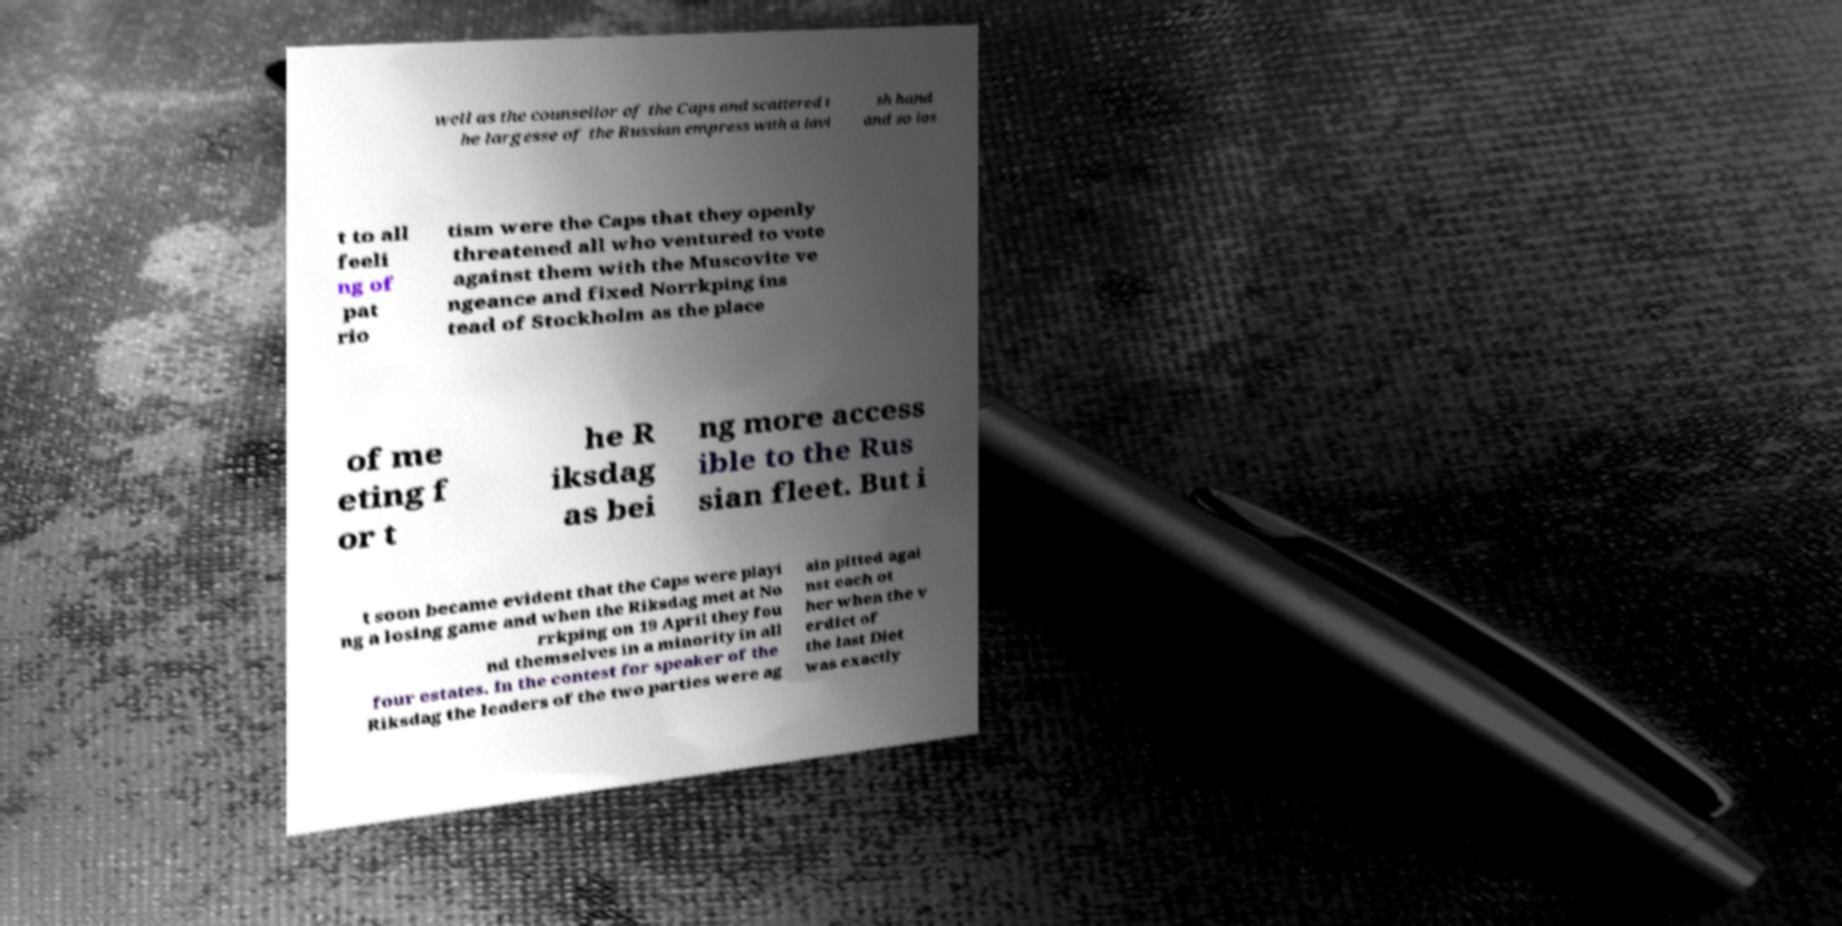What messages or text are displayed in this image? I need them in a readable, typed format. well as the counsellor of the Caps and scattered t he largesse of the Russian empress with a lavi sh hand and so los t to all feeli ng of pat rio tism were the Caps that they openly threatened all who ventured to vote against them with the Muscovite ve ngeance and fixed Norrkping ins tead of Stockholm as the place of me eting f or t he R iksdag as bei ng more access ible to the Rus sian fleet. But i t soon became evident that the Caps were playi ng a losing game and when the Riksdag met at No rrkping on 19 April they fou nd themselves in a minority in all four estates. In the contest for speaker of the Riksdag the leaders of the two parties were ag ain pitted agai nst each ot her when the v erdict of the last Diet was exactly 